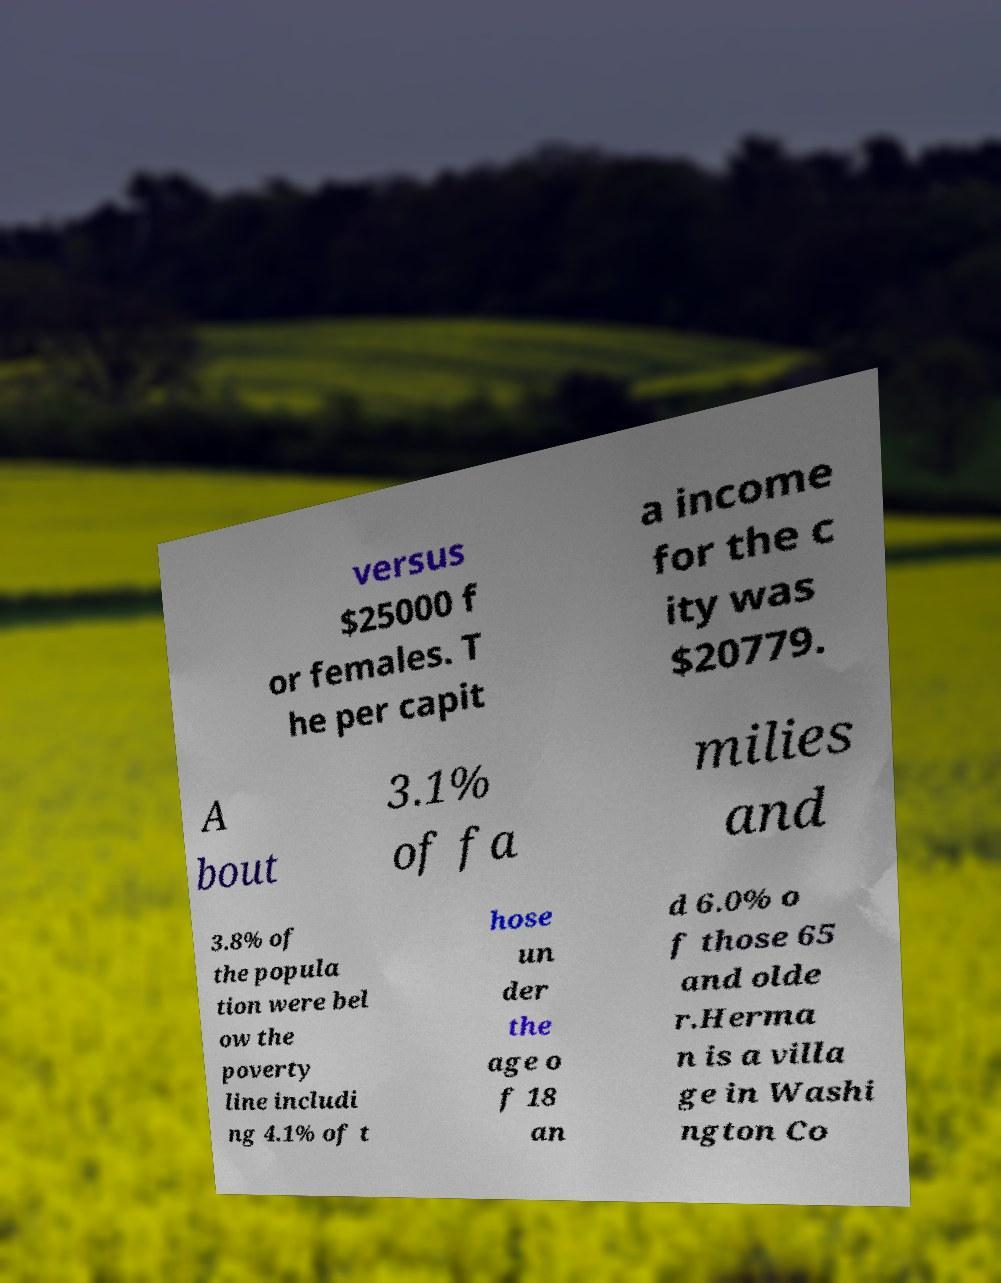Could you assist in decoding the text presented in this image and type it out clearly? versus $25000 f or females. T he per capit a income for the c ity was $20779. A bout 3.1% of fa milies and 3.8% of the popula tion were bel ow the poverty line includi ng 4.1% of t hose un der the age o f 18 an d 6.0% o f those 65 and olde r.Herma n is a villa ge in Washi ngton Co 